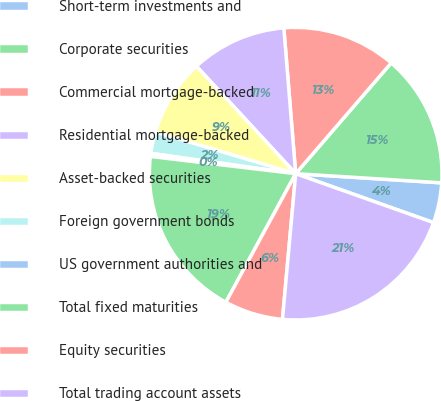<chart> <loc_0><loc_0><loc_500><loc_500><pie_chart><fcel>Short-term investments and<fcel>Corporate securities<fcel>Commercial mortgage-backed<fcel>Residential mortgage-backed<fcel>Asset-backed securities<fcel>Foreign government bonds<fcel>US government authorities and<fcel>Total fixed maturities<fcel>Equity securities<fcel>Total trading account assets<nl><fcel>4.43%<fcel>14.67%<fcel>12.62%<fcel>10.58%<fcel>8.53%<fcel>2.38%<fcel>0.34%<fcel>18.96%<fcel>6.48%<fcel>21.01%<nl></chart> 